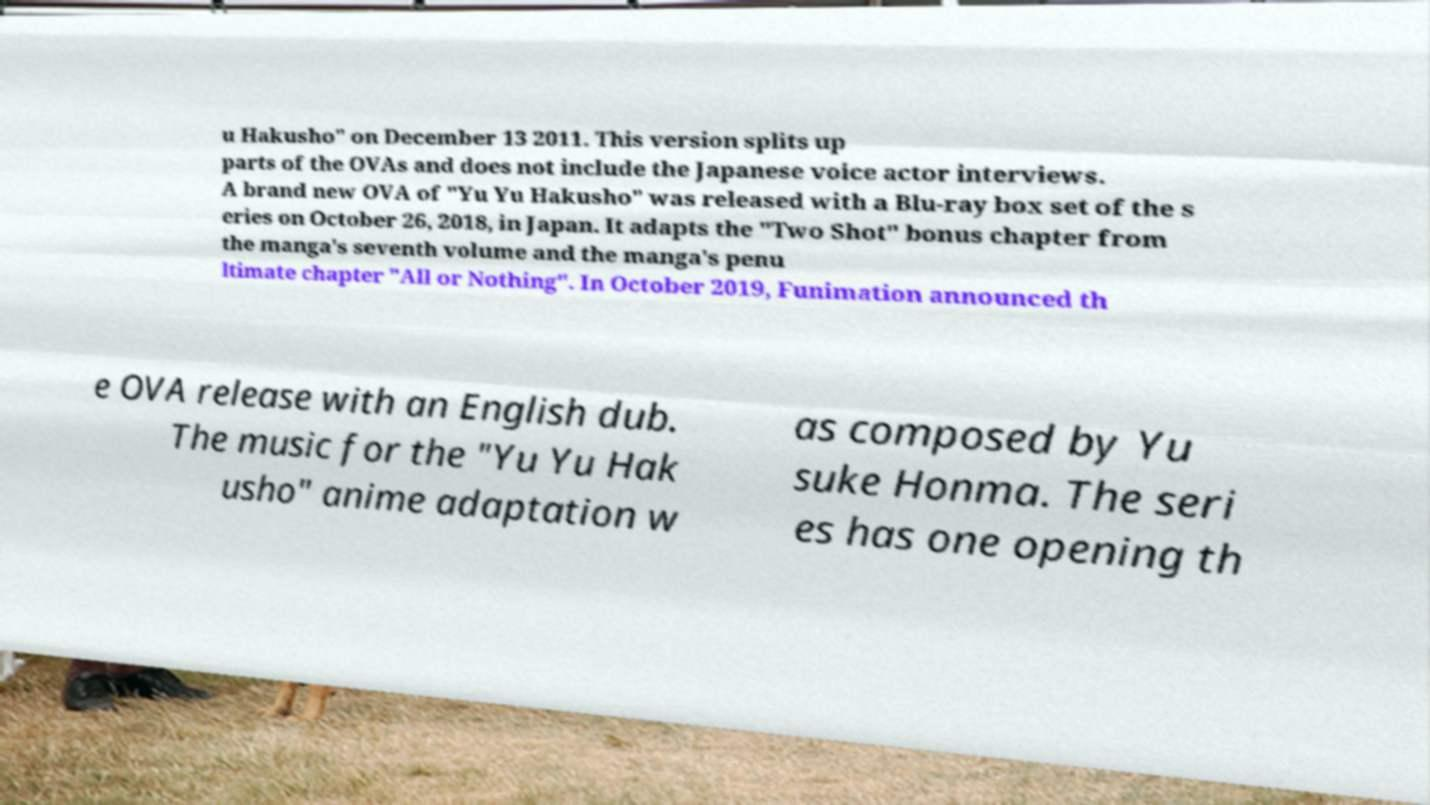Can you accurately transcribe the text from the provided image for me? u Hakusho" on December 13 2011. This version splits up parts of the OVAs and does not include the Japanese voice actor interviews. A brand new OVA of "Yu Yu Hakusho" was released with a Blu-ray box set of the s eries on October 26, 2018, in Japan. It adapts the "Two Shot" bonus chapter from the manga's seventh volume and the manga's penu ltimate chapter "All or Nothing". In October 2019, Funimation announced th e OVA release with an English dub. The music for the "Yu Yu Hak usho" anime adaptation w as composed by Yu suke Honma. The seri es has one opening th 